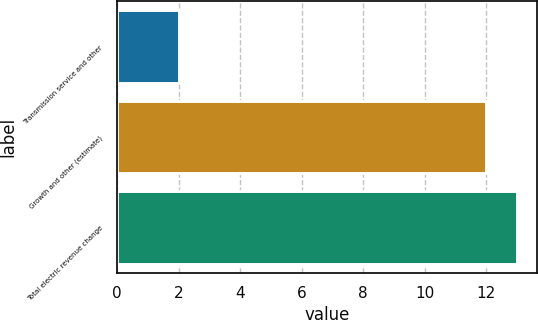Convert chart. <chart><loc_0><loc_0><loc_500><loc_500><bar_chart><fcel>Transmission service and other<fcel>Growth and other (estimate)<fcel>Total electric revenue change<nl><fcel>2<fcel>12<fcel>13<nl></chart> 